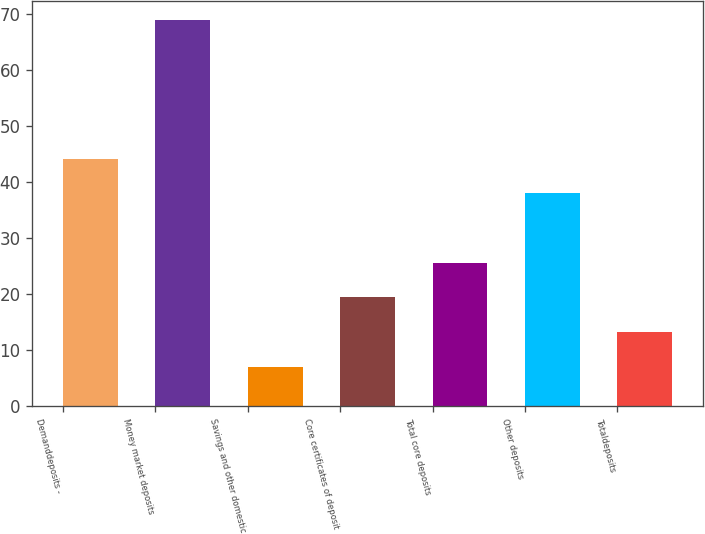Convert chart to OTSL. <chart><loc_0><loc_0><loc_500><loc_500><bar_chart><fcel>Demanddeposits -<fcel>Money market deposits<fcel>Savings and other domestic<fcel>Core certificates of deposit<fcel>Total core deposits<fcel>Other deposits<fcel>Totaldeposits<nl><fcel>44.2<fcel>69<fcel>7<fcel>19.4<fcel>25.6<fcel>38<fcel>13.2<nl></chart> 